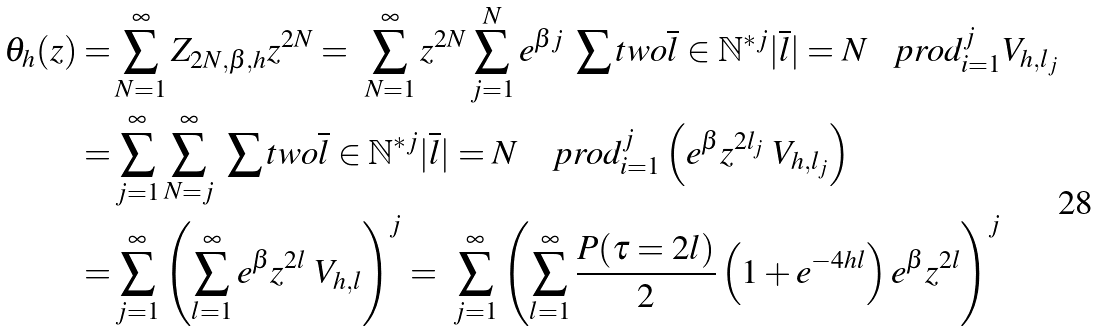Convert formula to latex. <formula><loc_0><loc_0><loc_500><loc_500>\theta _ { h } ( z ) = & \sum _ { N = 1 } ^ { \infty } Z _ { 2 N , \beta , h } z ^ { 2 N } = \ \sum _ { N = 1 } ^ { \infty } z ^ { 2 N } \sum _ { j = 1 } ^ { N } e ^ { \beta j } \ \sum t w o { \overline { l } \in \mathbb { N } ^ { * j } } { | \overline { l } | = N } \ \ \ p r o d _ { i = 1 } ^ { j } V _ { h , l _ { j } } \\ = & \sum _ { j = 1 } ^ { \infty } \sum _ { N = j } ^ { \infty } \ \sum t w o { \overline { l } \in \mathbb { N } ^ { * j } } { | \overline { l } | = N } \quad p r o d _ { i = 1 } ^ { j } \left ( e ^ { \beta } z ^ { 2 l _ { j } } \ V _ { h , l _ { j } } \right ) \\ = & \sum _ { j = 1 } ^ { \infty } \left ( \sum _ { l = 1 } ^ { \infty } e ^ { \beta } z ^ { 2 l } \ V _ { h , l } \right ) ^ { j } = \ \sum _ { j = 1 } ^ { \infty } \left ( \sum _ { l = 1 } ^ { \infty } \frac { P ( \tau = 2 l ) } { 2 } \left ( 1 + e ^ { - 4 h l } \right ) e ^ { \beta } z ^ { 2 l } \right ) ^ { j } \\</formula> 